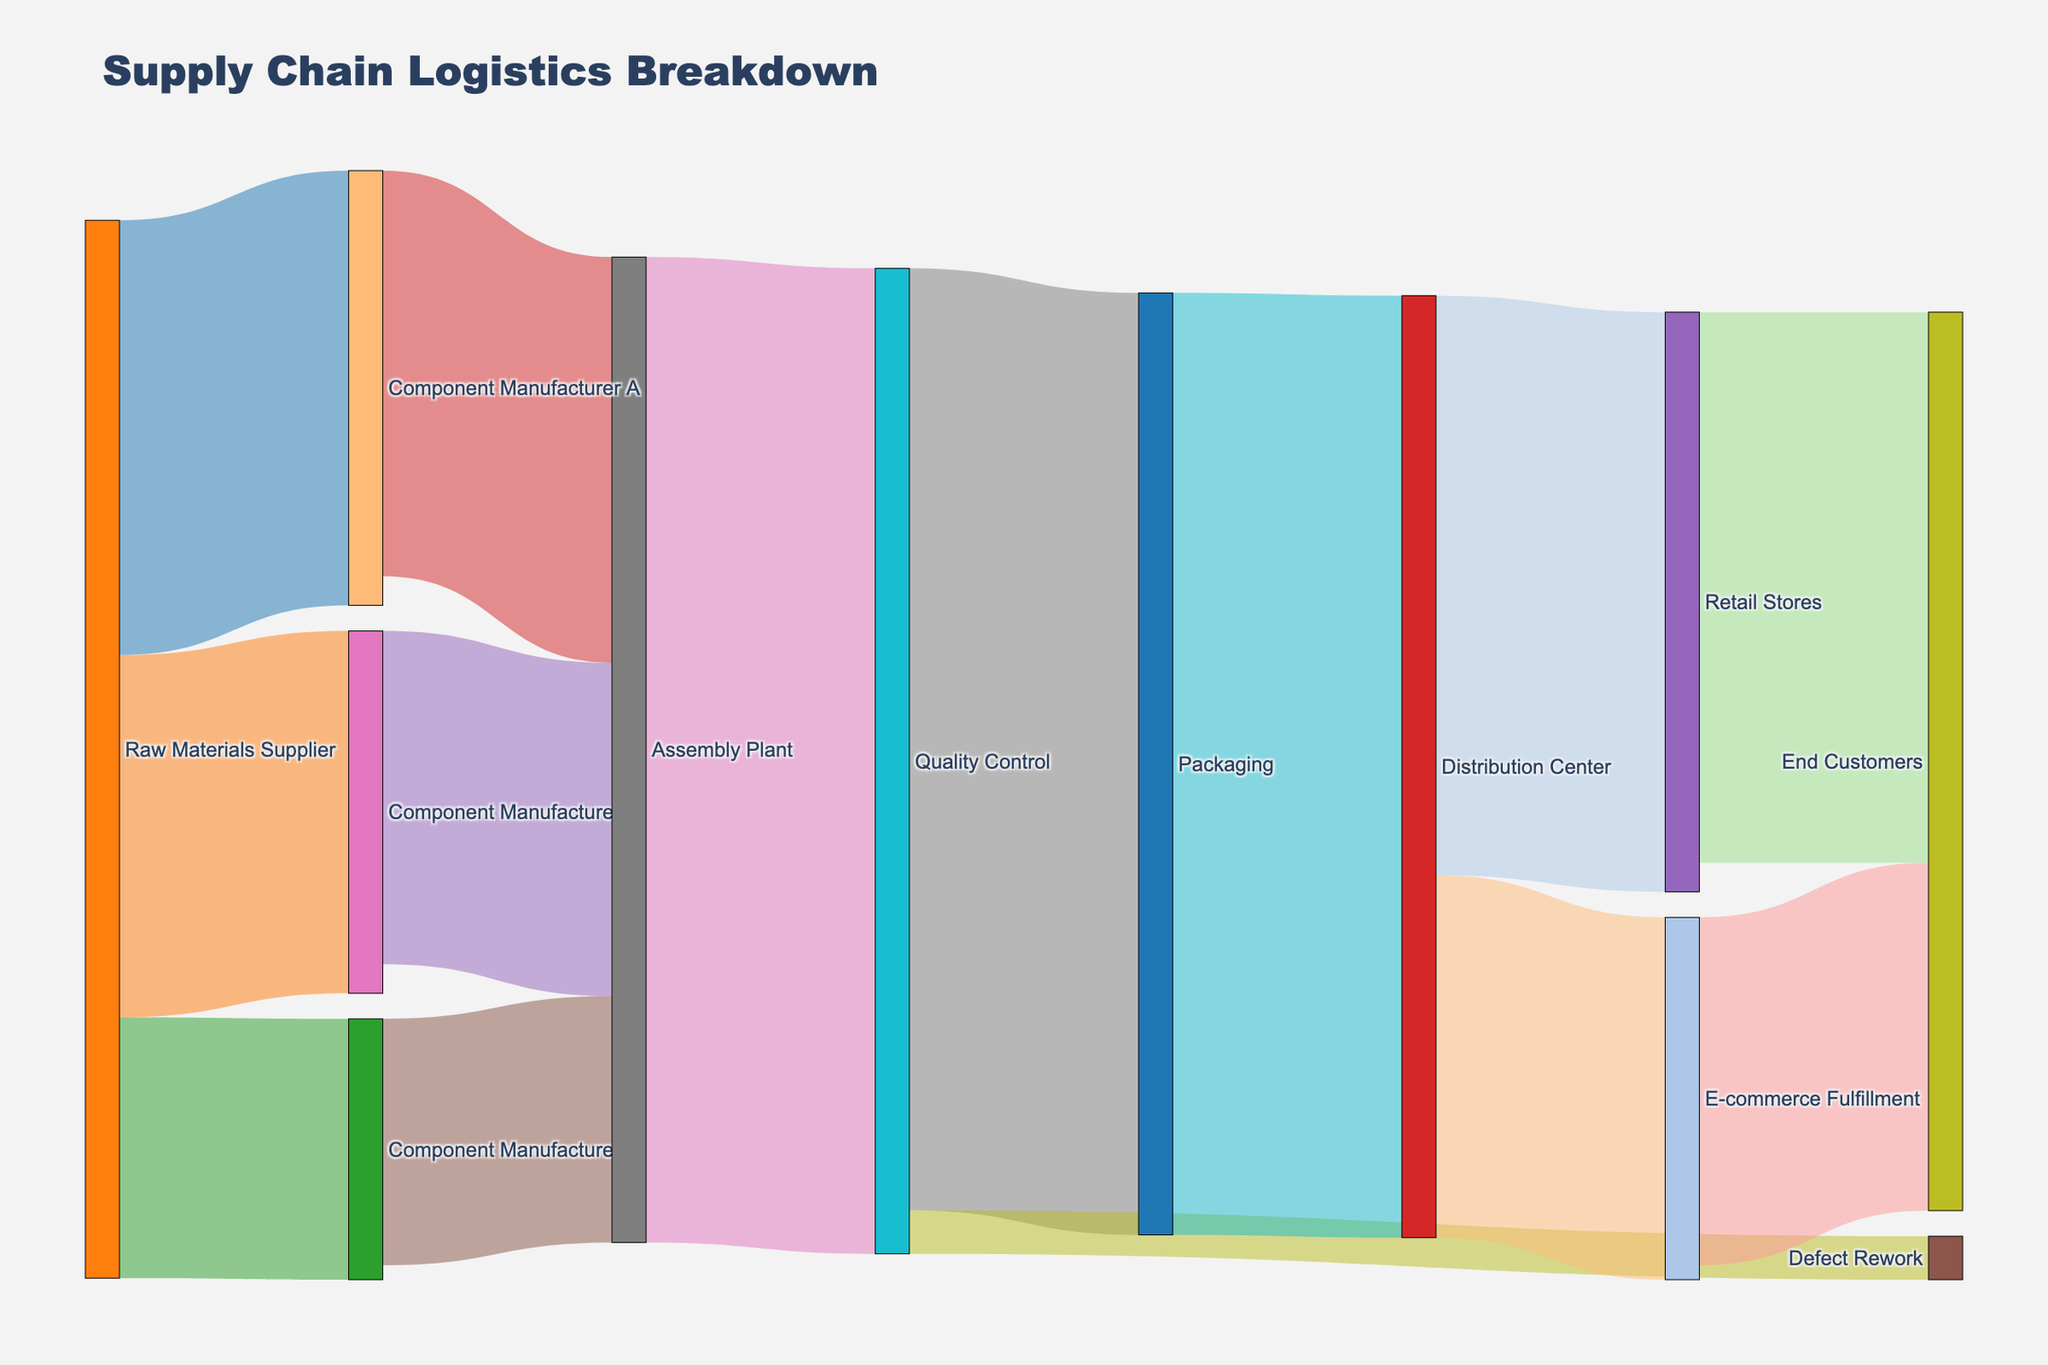what is the origin of the flow ending at "Assembly Plant"? The nodes connected to "Assembly Plant" are analyzed. "Component Manufacturer A" (2800), "Component Manufacturer B" (2300), and "Component Manufacturer C" (1700) all direct their flow towards "Assembly Plant". Summing these provides the total inflow to "Assembly Plant".
Answer: Component Manufacturer A, B, C Which node has the most outflow to "End Customers"? "Retail Stores" flow to "End Customers" is 3800 units, while "E-commerce Fulfillment" flow to "End Customers" is 2400 units. Comparing these two values shows "Retail Stores" has the greater outflow.
Answer: Retail Stores How much flow does "Quality Control" direct to "Defect Rework"? Inspect the link value associated with "Quality Control" to "Defect Rework", which is directly provided in the Sankey diagram data.
Answer: 300 units What total flow passes through the "Packaging" node? Analyzing the flow coming into and out of "Packaging," flows are aggregated. Flow into "Packaging" from "Quality Control" is 6500 units. The same amount flows out from "Packaging" to "Distribution Center."
Answer: 6500 units How many nodes are there in total in this Sankey diagram? Review the total count of unique nodes listed in both the 'source' and 'target' columns, then take the union of these lists.
Answer: 12 nodes What is the ratio of flow from "Distribution Center" to "Retail Stores" compared to "E-commerce Fulfillment"? The flow from "Distribution Center" to "Retail Stores" is 4000, and to "E-commerce Fulfillment" is 2500. The ratio is calculated by dividing the former by the latter.
Answer: 1.6 Which node has the most significant flow into it? By examining the maximum cumulative inflow into a single node, it's determined that the "End Customers" node receives the highest cumulative inflow (3800 from Retail Stores + 2400 from E-commerce Fulfillment).
Answer: End Customers What is the total outflow from the "Raw Materials Supplier"? The outflows from "Raw Materials Supplier" are summed by adding 3000 (to Component Manufacturer A), 2500 (to Component Manufacturer B), and 1800 (to Component Manufacturer C).
Answer: 7300 units 